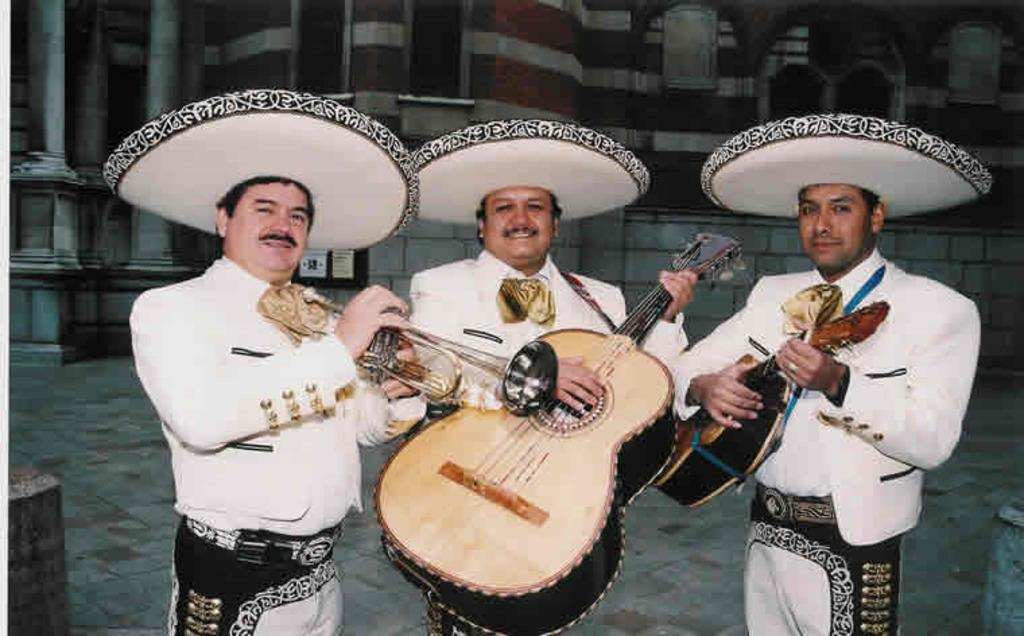How many people are present in the image? There are three people in the image. What are the people doing in the image? The three people are holding musical instruments. What can be seen in the background of the image? There is a building in the background of the image. What type of vegetable is being played by the person on the left in the image? There is no vegetable present in the image; the people are holding musical instruments. What is the weight of the mice that are visible in the image? There are no mice present in the image. 